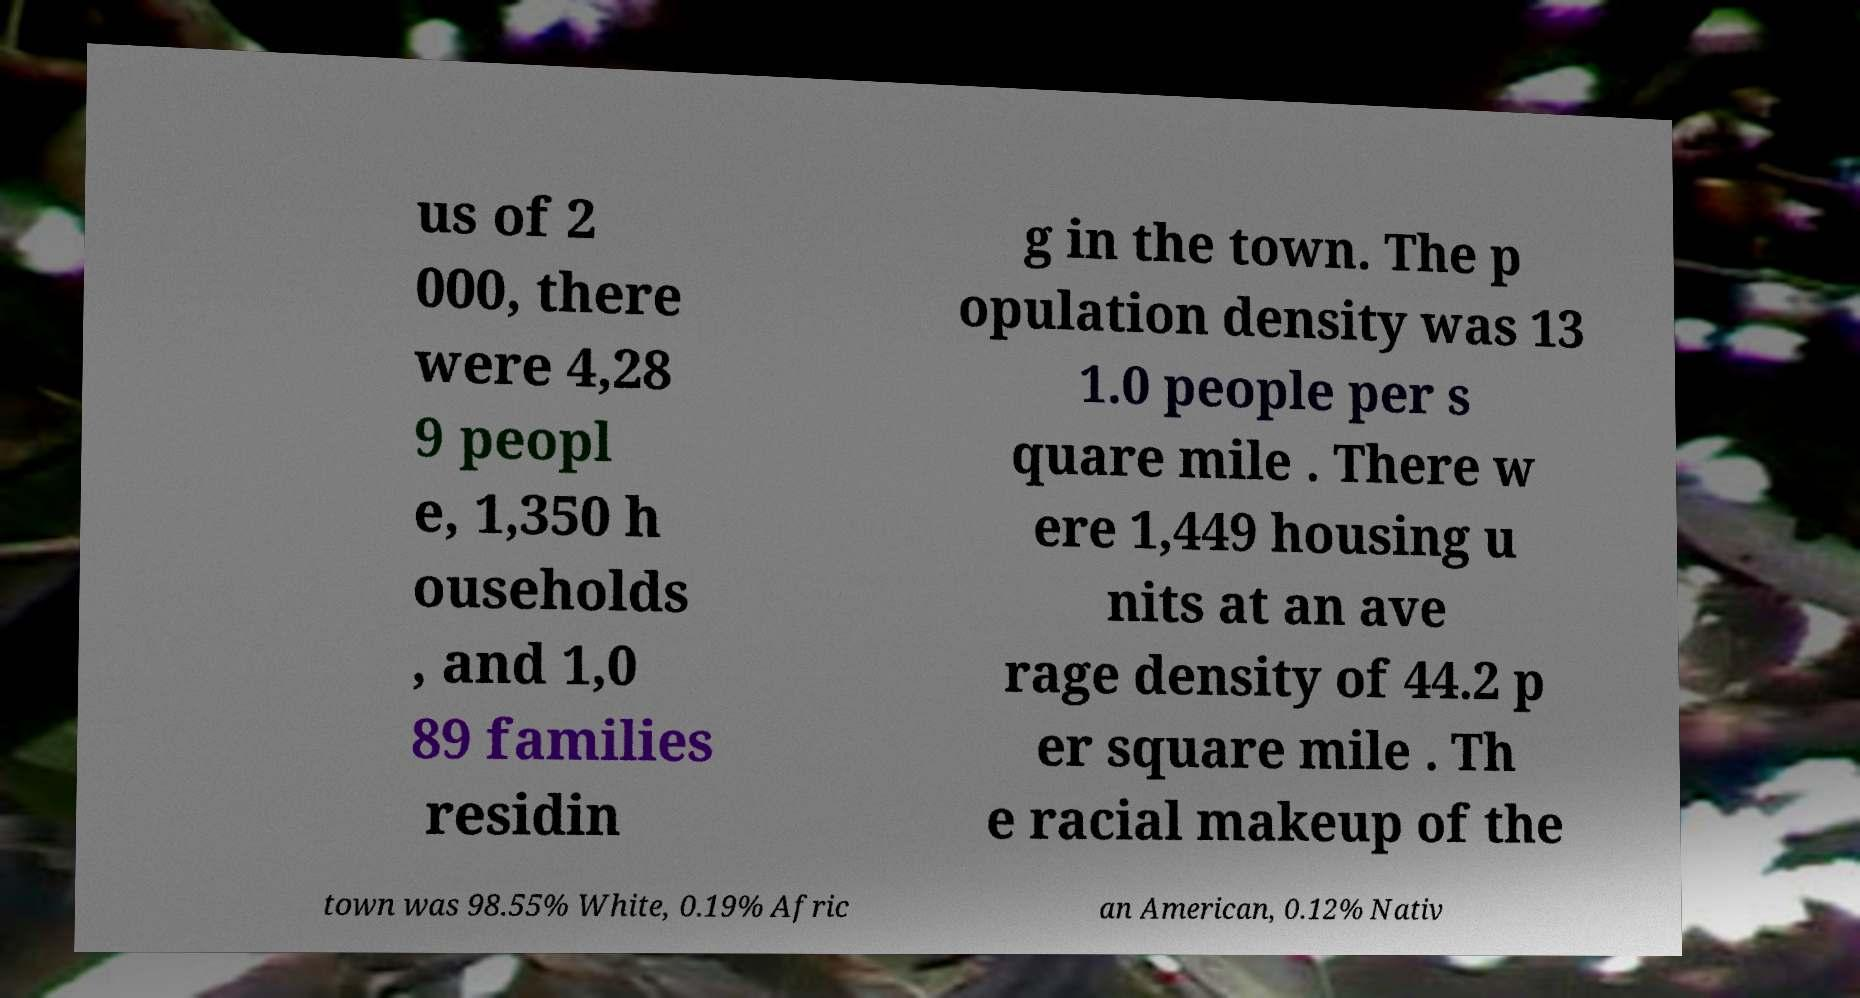There's text embedded in this image that I need extracted. Can you transcribe it verbatim? us of 2 000, there were 4,28 9 peopl e, 1,350 h ouseholds , and 1,0 89 families residin g in the town. The p opulation density was 13 1.0 people per s quare mile . There w ere 1,449 housing u nits at an ave rage density of 44.2 p er square mile . Th e racial makeup of the town was 98.55% White, 0.19% Afric an American, 0.12% Nativ 